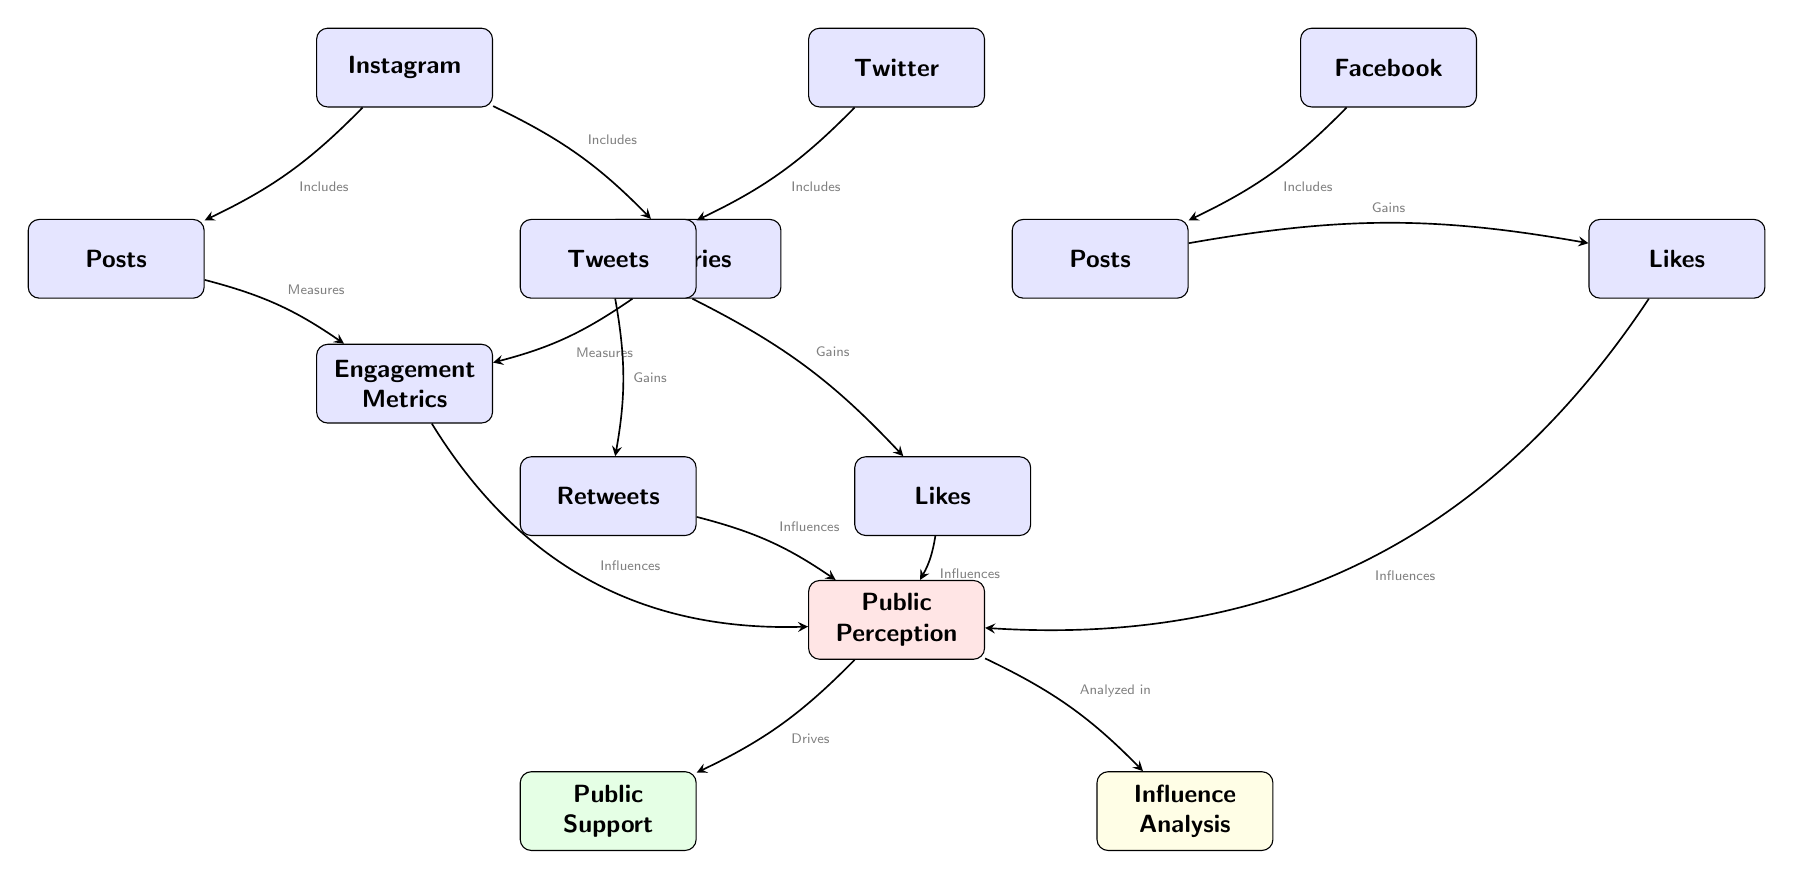What social media platform includes posts and stories? The diagram indicates that Instagram includes both posts and stories, as shown by the edges connecting these nodes to the Instagram node.
Answer: Instagram How many engagement metrics are mentioned under Instagram? The diagram lists only one engagement metrics node under Instagram, indicating that it measures engagement, therefore the count is one.
Answer: 1 What type of engagement does Twitter primarily gain through tweets? The diagram shows that Twitter gains both retweets and likes from tweets, indicating that these are the primary engagements connected to the Twitter tweets node.
Answer: Retweets and Likes Which social media platform has the least engagement metrics influencing public perception? The diagram illustrates that Facebook has fewer engagement types, with only posts leading to likes, in comparison to Instagram and Twitter. Thus, it has the least.
Answer: Facebook What node drives public support? According to the diagram, public perception directly drives public support, as there is an edge demonstrating this relationship from public perception to support.
Answer: Public Perception Which platform has stories as a type of engagement? The diagram explicitly states that Instagram includes stories, indicating that it is the platform that features this type of engagement.
Answer: Instagram What influence does Instagram engagement have on public perception? The diagram indicates that Instagram engagement influences public perception as it is directed from the Instagram engagement metrics node to the public perception node.
Answer: Influences How does Twitter engage users through its tweets? The diagram specifies that Twitter engages users by gaining retweets and likes from tweets, which are forms of user interaction.
Answer: Gaining retweets and likes What does public perception analyze in this diagram? The diagram shows that public perception is analyzed in the influence analysis node, suggesting it relates to understanding how social media influences perceptions.
Answer: Influence Analysis What is the connecting relationship between public perception and public support? The diagram illustrates a direct relationship where public perception drives public support, indicating a cause-effect link between these two nodes.
Answer: Drives 